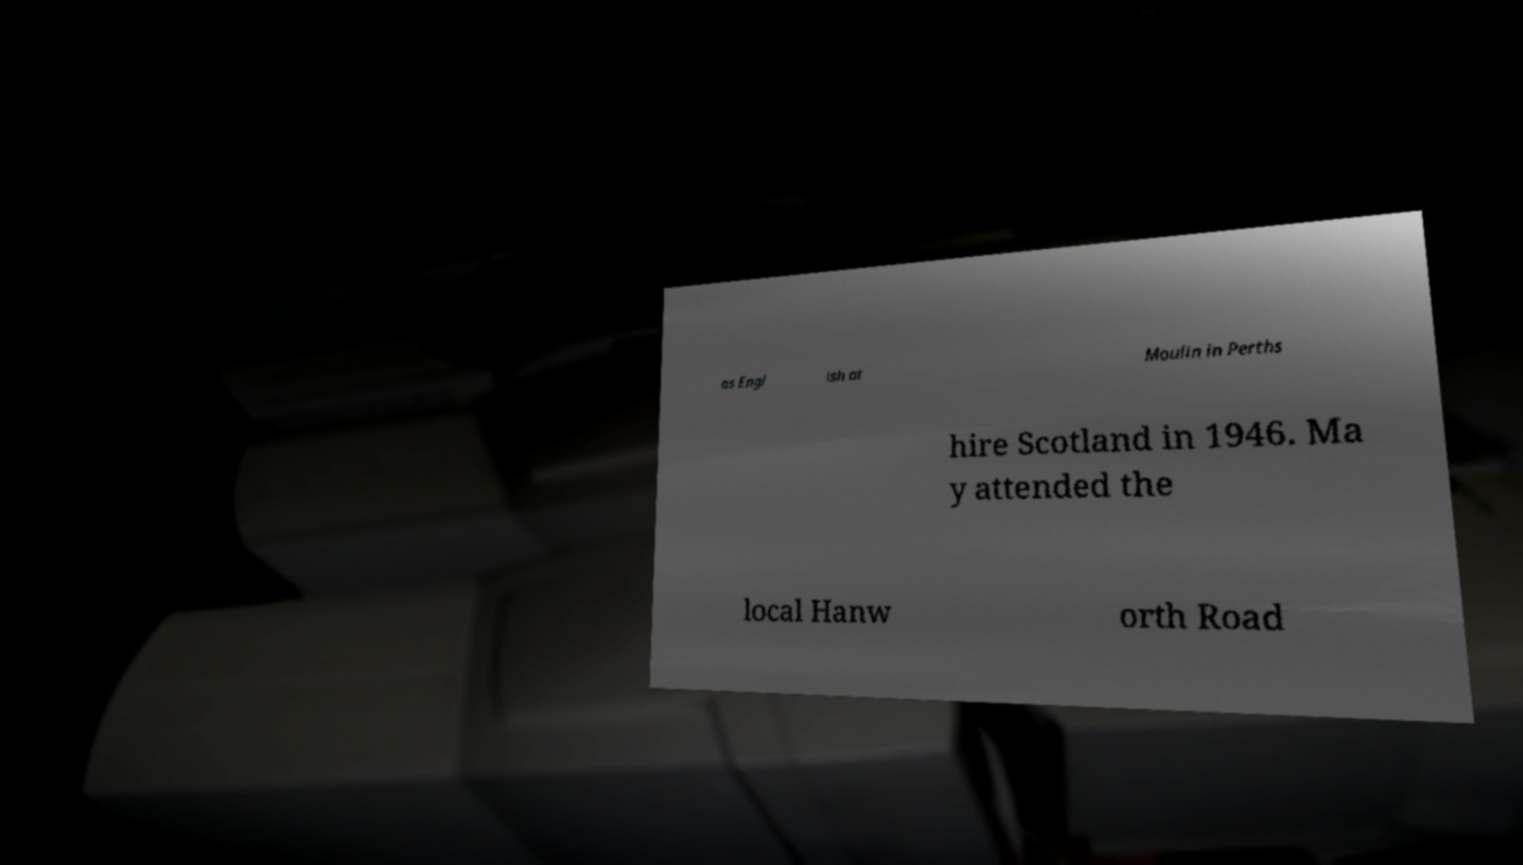Please identify and transcribe the text found in this image. as Engl ish at Moulin in Perths hire Scotland in 1946. Ma y attended the local Hanw orth Road 